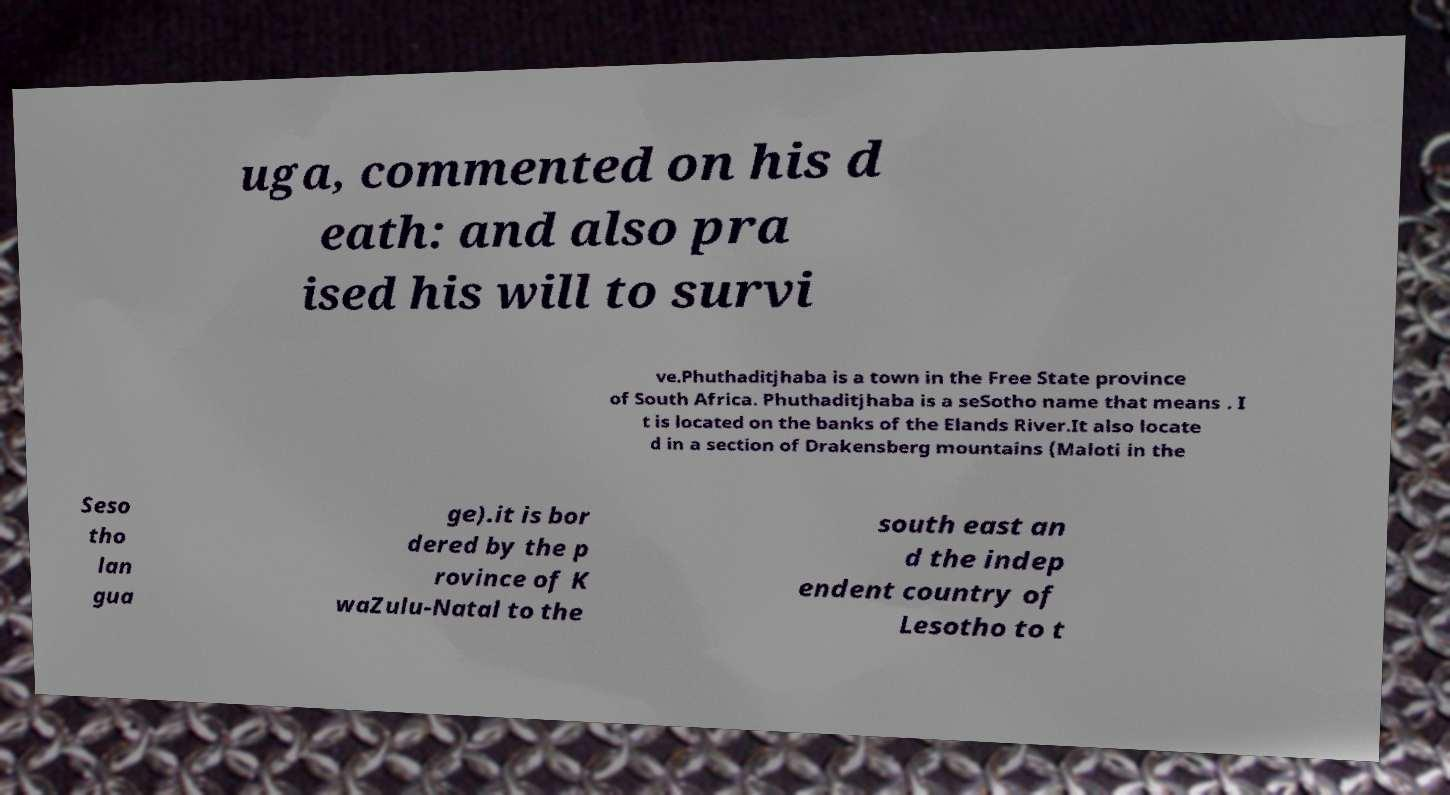There's text embedded in this image that I need extracted. Can you transcribe it verbatim? uga, commented on his d eath: and also pra ised his will to survi ve.Phuthaditjhaba is a town in the Free State province of South Africa. Phuthaditjhaba is a seSotho name that means . I t is located on the banks of the Elands River.It also locate d in a section of Drakensberg mountains (Maloti in the Seso tho lan gua ge).it is bor dered by the p rovince of K waZulu-Natal to the south east an d the indep endent country of Lesotho to t 